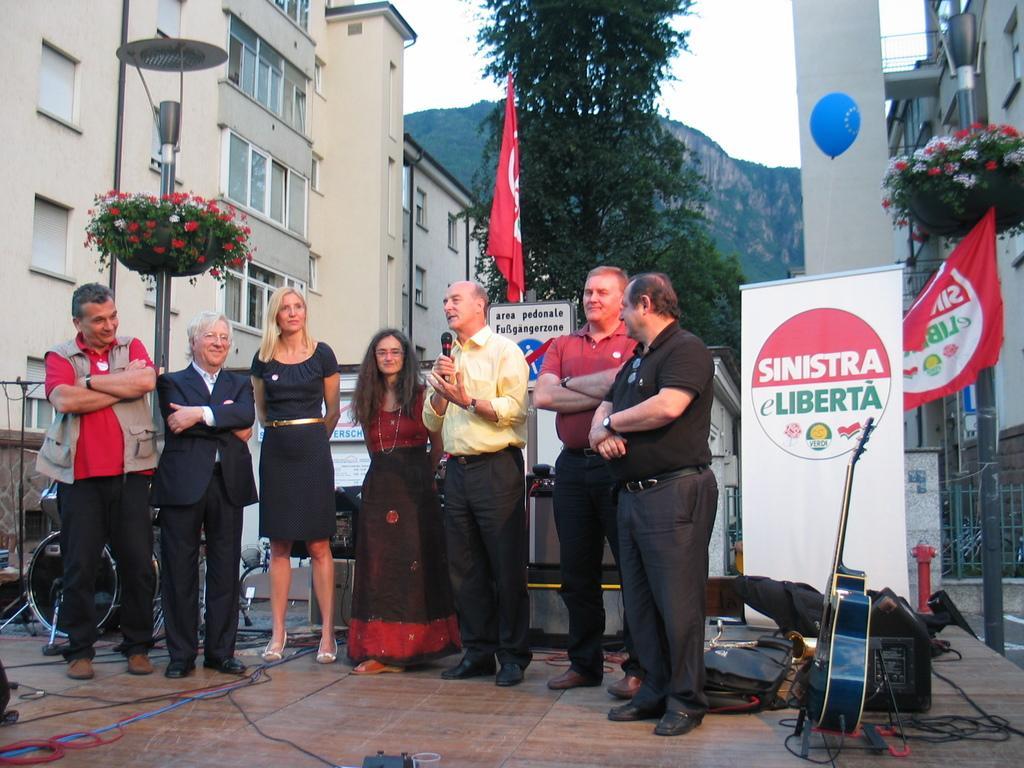Can you describe this image briefly? This is an outside view. Here I can see few people are standing and smiling. One man is holding a mike in the hand and speaking. At the back of these people there are some musical instruments, cables, bags and some other objects. On the right side there is a guitar placed on the floor. Behind there is a banner on which I can see some text. On the right and left side of the image there are two poles. In the background there are many buildings and trees and also I can see a hill. At the top of the image I can see the sky. 